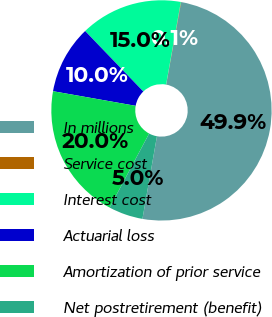<chart> <loc_0><loc_0><loc_500><loc_500><pie_chart><fcel>In millions<fcel>Service cost<fcel>Interest cost<fcel>Actuarial loss<fcel>Amortization of prior service<fcel>Net postretirement (benefit)<nl><fcel>49.9%<fcel>0.05%<fcel>15.0%<fcel>10.02%<fcel>19.99%<fcel>5.03%<nl></chart> 